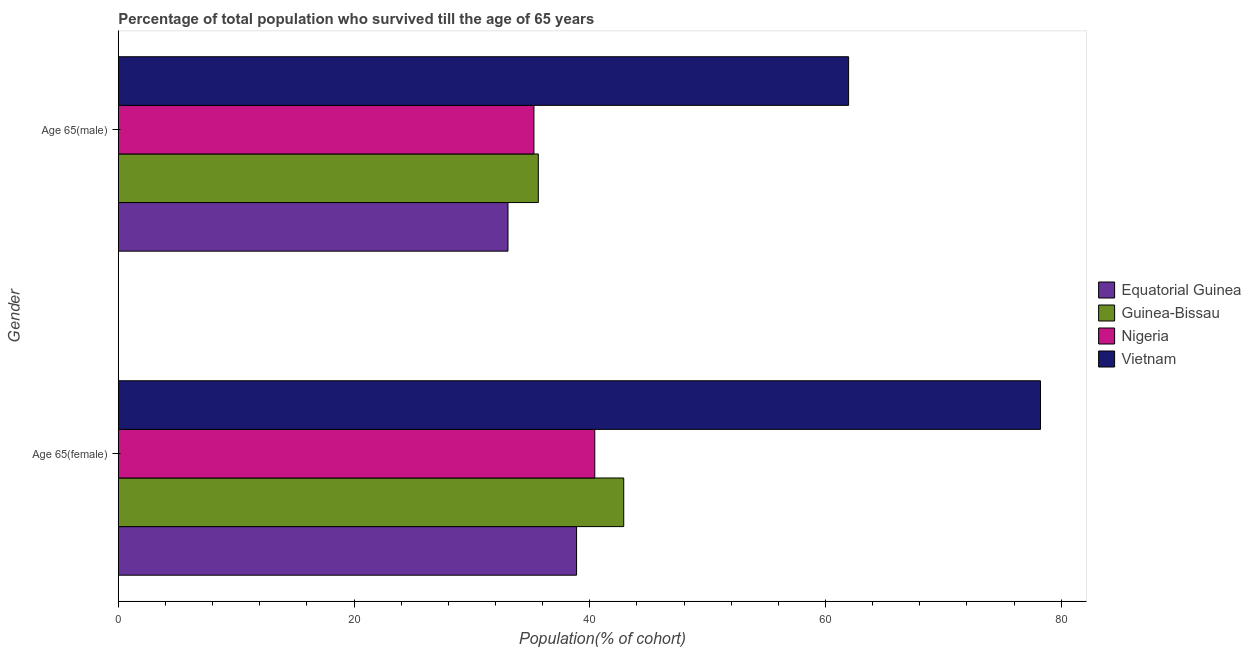How many different coloured bars are there?
Provide a succinct answer. 4. How many groups of bars are there?
Give a very brief answer. 2. Are the number of bars on each tick of the Y-axis equal?
Your answer should be very brief. Yes. How many bars are there on the 2nd tick from the top?
Your answer should be compact. 4. What is the label of the 2nd group of bars from the top?
Offer a very short reply. Age 65(female). What is the percentage of female population who survived till age of 65 in Equatorial Guinea?
Ensure brevity in your answer.  38.88. Across all countries, what is the maximum percentage of female population who survived till age of 65?
Keep it short and to the point. 78.24. Across all countries, what is the minimum percentage of female population who survived till age of 65?
Your response must be concise. 38.88. In which country was the percentage of male population who survived till age of 65 maximum?
Offer a very short reply. Vietnam. In which country was the percentage of female population who survived till age of 65 minimum?
Your answer should be compact. Equatorial Guinea. What is the total percentage of male population who survived till age of 65 in the graph?
Provide a short and direct response. 165.92. What is the difference between the percentage of female population who survived till age of 65 in Nigeria and that in Equatorial Guinea?
Your answer should be very brief. 1.54. What is the difference between the percentage of male population who survived till age of 65 in Nigeria and the percentage of female population who survived till age of 65 in Equatorial Guinea?
Keep it short and to the point. -3.62. What is the average percentage of female population who survived till age of 65 per country?
Your answer should be compact. 50.11. What is the difference between the percentage of female population who survived till age of 65 and percentage of male population who survived till age of 65 in Equatorial Guinea?
Your response must be concise. 5.82. In how many countries, is the percentage of male population who survived till age of 65 greater than 16 %?
Your response must be concise. 4. What is the ratio of the percentage of female population who survived till age of 65 in Guinea-Bissau to that in Vietnam?
Make the answer very short. 0.55. Is the percentage of female population who survived till age of 65 in Vietnam less than that in Guinea-Bissau?
Make the answer very short. No. What does the 3rd bar from the top in Age 65(female) represents?
Keep it short and to the point. Guinea-Bissau. What does the 4th bar from the bottom in Age 65(female) represents?
Your answer should be compact. Vietnam. Are all the bars in the graph horizontal?
Your response must be concise. Yes. Where does the legend appear in the graph?
Offer a very short reply. Center right. How are the legend labels stacked?
Keep it short and to the point. Vertical. What is the title of the graph?
Make the answer very short. Percentage of total population who survived till the age of 65 years. What is the label or title of the X-axis?
Your response must be concise. Population(% of cohort). What is the label or title of the Y-axis?
Keep it short and to the point. Gender. What is the Population(% of cohort) in Equatorial Guinea in Age 65(female)?
Make the answer very short. 38.88. What is the Population(% of cohort) in Guinea-Bissau in Age 65(female)?
Make the answer very short. 42.88. What is the Population(% of cohort) in Nigeria in Age 65(female)?
Provide a succinct answer. 40.42. What is the Population(% of cohort) in Vietnam in Age 65(female)?
Your answer should be very brief. 78.24. What is the Population(% of cohort) of Equatorial Guinea in Age 65(male)?
Your response must be concise. 33.06. What is the Population(% of cohort) in Guinea-Bissau in Age 65(male)?
Provide a short and direct response. 35.63. What is the Population(% of cohort) in Nigeria in Age 65(male)?
Your answer should be compact. 35.26. What is the Population(% of cohort) in Vietnam in Age 65(male)?
Offer a very short reply. 61.96. Across all Gender, what is the maximum Population(% of cohort) of Equatorial Guinea?
Your response must be concise. 38.88. Across all Gender, what is the maximum Population(% of cohort) in Guinea-Bissau?
Provide a succinct answer. 42.88. Across all Gender, what is the maximum Population(% of cohort) of Nigeria?
Your answer should be very brief. 40.42. Across all Gender, what is the maximum Population(% of cohort) of Vietnam?
Offer a terse response. 78.24. Across all Gender, what is the minimum Population(% of cohort) of Equatorial Guinea?
Your answer should be compact. 33.06. Across all Gender, what is the minimum Population(% of cohort) in Guinea-Bissau?
Give a very brief answer. 35.63. Across all Gender, what is the minimum Population(% of cohort) of Nigeria?
Your answer should be compact. 35.26. Across all Gender, what is the minimum Population(% of cohort) of Vietnam?
Give a very brief answer. 61.96. What is the total Population(% of cohort) of Equatorial Guinea in the graph?
Offer a very short reply. 71.94. What is the total Population(% of cohort) in Guinea-Bissau in the graph?
Keep it short and to the point. 78.52. What is the total Population(% of cohort) in Nigeria in the graph?
Ensure brevity in your answer.  75.69. What is the total Population(% of cohort) in Vietnam in the graph?
Your answer should be compact. 140.2. What is the difference between the Population(% of cohort) of Equatorial Guinea in Age 65(female) and that in Age 65(male)?
Your response must be concise. 5.82. What is the difference between the Population(% of cohort) in Guinea-Bissau in Age 65(female) and that in Age 65(male)?
Provide a short and direct response. 7.25. What is the difference between the Population(% of cohort) of Nigeria in Age 65(female) and that in Age 65(male)?
Offer a terse response. 5.16. What is the difference between the Population(% of cohort) of Vietnam in Age 65(female) and that in Age 65(male)?
Your response must be concise. 16.28. What is the difference between the Population(% of cohort) in Equatorial Guinea in Age 65(female) and the Population(% of cohort) in Guinea-Bissau in Age 65(male)?
Make the answer very short. 3.25. What is the difference between the Population(% of cohort) of Equatorial Guinea in Age 65(female) and the Population(% of cohort) of Nigeria in Age 65(male)?
Make the answer very short. 3.62. What is the difference between the Population(% of cohort) of Equatorial Guinea in Age 65(female) and the Population(% of cohort) of Vietnam in Age 65(male)?
Your answer should be compact. -23.08. What is the difference between the Population(% of cohort) in Guinea-Bissau in Age 65(female) and the Population(% of cohort) in Nigeria in Age 65(male)?
Ensure brevity in your answer.  7.62. What is the difference between the Population(% of cohort) of Guinea-Bissau in Age 65(female) and the Population(% of cohort) of Vietnam in Age 65(male)?
Offer a terse response. -19.08. What is the difference between the Population(% of cohort) in Nigeria in Age 65(female) and the Population(% of cohort) in Vietnam in Age 65(male)?
Provide a succinct answer. -21.54. What is the average Population(% of cohort) in Equatorial Guinea per Gender?
Offer a terse response. 35.97. What is the average Population(% of cohort) of Guinea-Bissau per Gender?
Give a very brief answer. 39.26. What is the average Population(% of cohort) in Nigeria per Gender?
Keep it short and to the point. 37.84. What is the average Population(% of cohort) in Vietnam per Gender?
Your answer should be very brief. 70.1. What is the difference between the Population(% of cohort) in Equatorial Guinea and Population(% of cohort) in Guinea-Bissau in Age 65(female)?
Keep it short and to the point. -4. What is the difference between the Population(% of cohort) of Equatorial Guinea and Population(% of cohort) of Nigeria in Age 65(female)?
Offer a terse response. -1.54. What is the difference between the Population(% of cohort) in Equatorial Guinea and Population(% of cohort) in Vietnam in Age 65(female)?
Provide a succinct answer. -39.36. What is the difference between the Population(% of cohort) of Guinea-Bissau and Population(% of cohort) of Nigeria in Age 65(female)?
Offer a very short reply. 2.46. What is the difference between the Population(% of cohort) of Guinea-Bissau and Population(% of cohort) of Vietnam in Age 65(female)?
Keep it short and to the point. -35.36. What is the difference between the Population(% of cohort) in Nigeria and Population(% of cohort) in Vietnam in Age 65(female)?
Your answer should be very brief. -37.81. What is the difference between the Population(% of cohort) of Equatorial Guinea and Population(% of cohort) of Guinea-Bissau in Age 65(male)?
Provide a short and direct response. -2.57. What is the difference between the Population(% of cohort) of Equatorial Guinea and Population(% of cohort) of Nigeria in Age 65(male)?
Keep it short and to the point. -2.2. What is the difference between the Population(% of cohort) of Equatorial Guinea and Population(% of cohort) of Vietnam in Age 65(male)?
Offer a terse response. -28.9. What is the difference between the Population(% of cohort) in Guinea-Bissau and Population(% of cohort) in Nigeria in Age 65(male)?
Provide a succinct answer. 0.37. What is the difference between the Population(% of cohort) in Guinea-Bissau and Population(% of cohort) in Vietnam in Age 65(male)?
Offer a very short reply. -26.33. What is the difference between the Population(% of cohort) of Nigeria and Population(% of cohort) of Vietnam in Age 65(male)?
Your answer should be very brief. -26.7. What is the ratio of the Population(% of cohort) in Equatorial Guinea in Age 65(female) to that in Age 65(male)?
Your answer should be compact. 1.18. What is the ratio of the Population(% of cohort) in Guinea-Bissau in Age 65(female) to that in Age 65(male)?
Ensure brevity in your answer.  1.2. What is the ratio of the Population(% of cohort) of Nigeria in Age 65(female) to that in Age 65(male)?
Your answer should be compact. 1.15. What is the ratio of the Population(% of cohort) of Vietnam in Age 65(female) to that in Age 65(male)?
Provide a succinct answer. 1.26. What is the difference between the highest and the second highest Population(% of cohort) in Equatorial Guinea?
Offer a very short reply. 5.82. What is the difference between the highest and the second highest Population(% of cohort) in Guinea-Bissau?
Offer a terse response. 7.25. What is the difference between the highest and the second highest Population(% of cohort) in Nigeria?
Ensure brevity in your answer.  5.16. What is the difference between the highest and the second highest Population(% of cohort) of Vietnam?
Provide a succinct answer. 16.28. What is the difference between the highest and the lowest Population(% of cohort) of Equatorial Guinea?
Make the answer very short. 5.82. What is the difference between the highest and the lowest Population(% of cohort) of Guinea-Bissau?
Make the answer very short. 7.25. What is the difference between the highest and the lowest Population(% of cohort) in Nigeria?
Make the answer very short. 5.16. What is the difference between the highest and the lowest Population(% of cohort) of Vietnam?
Provide a short and direct response. 16.28. 